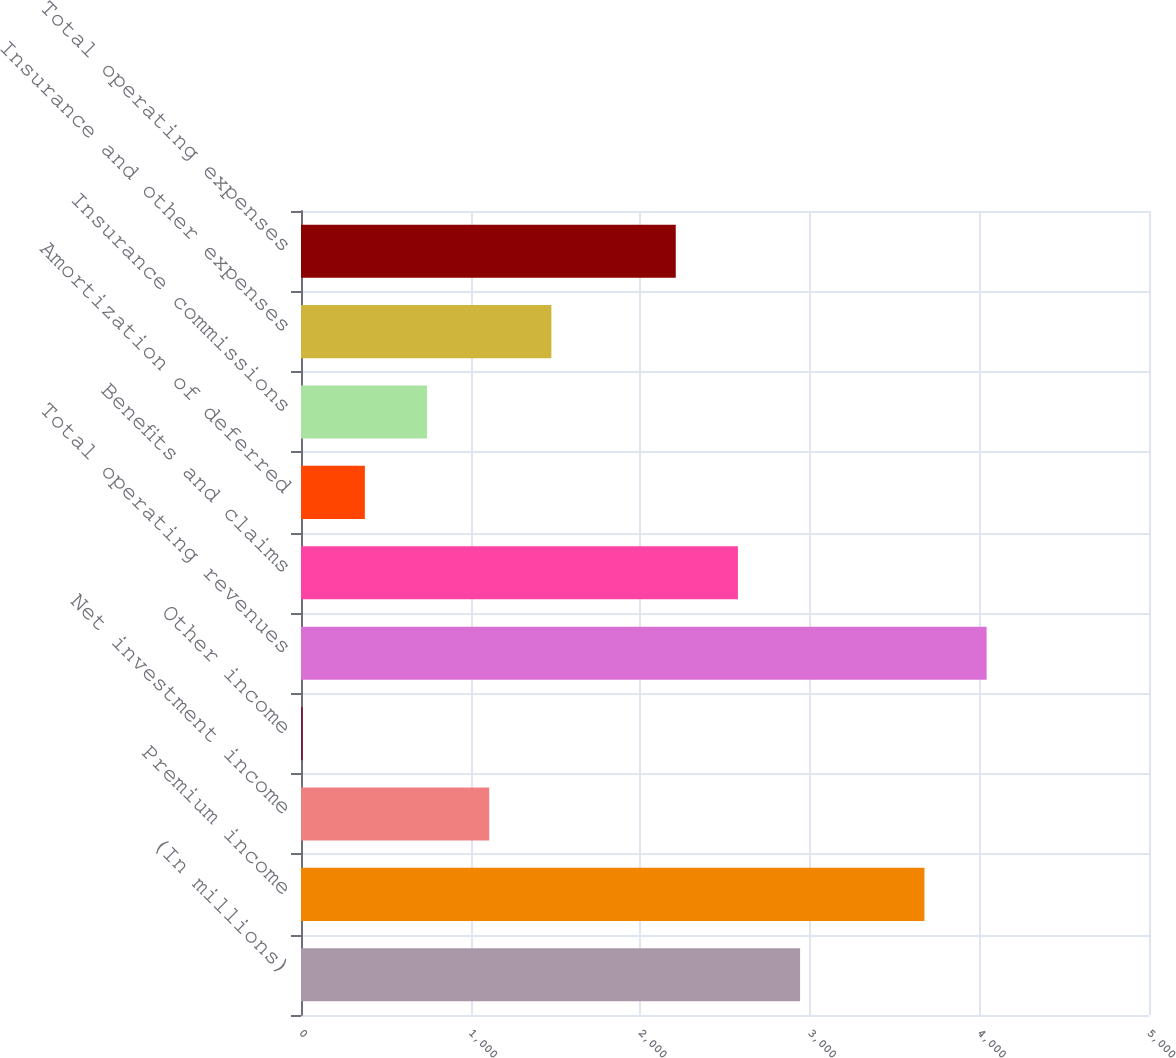<chart> <loc_0><loc_0><loc_500><loc_500><bar_chart><fcel>(In millions)<fcel>Premium income<fcel>Net investment income<fcel>Other income<fcel>Total operating revenues<fcel>Benefits and claims<fcel>Amortization of deferred<fcel>Insurance commissions<fcel>Insurance and other expenses<fcel>Total operating expenses<nl><fcel>2942.8<fcel>3676<fcel>1109.8<fcel>10<fcel>4042.6<fcel>2576.2<fcel>376.6<fcel>743.2<fcel>1476.4<fcel>2209.6<nl></chart> 